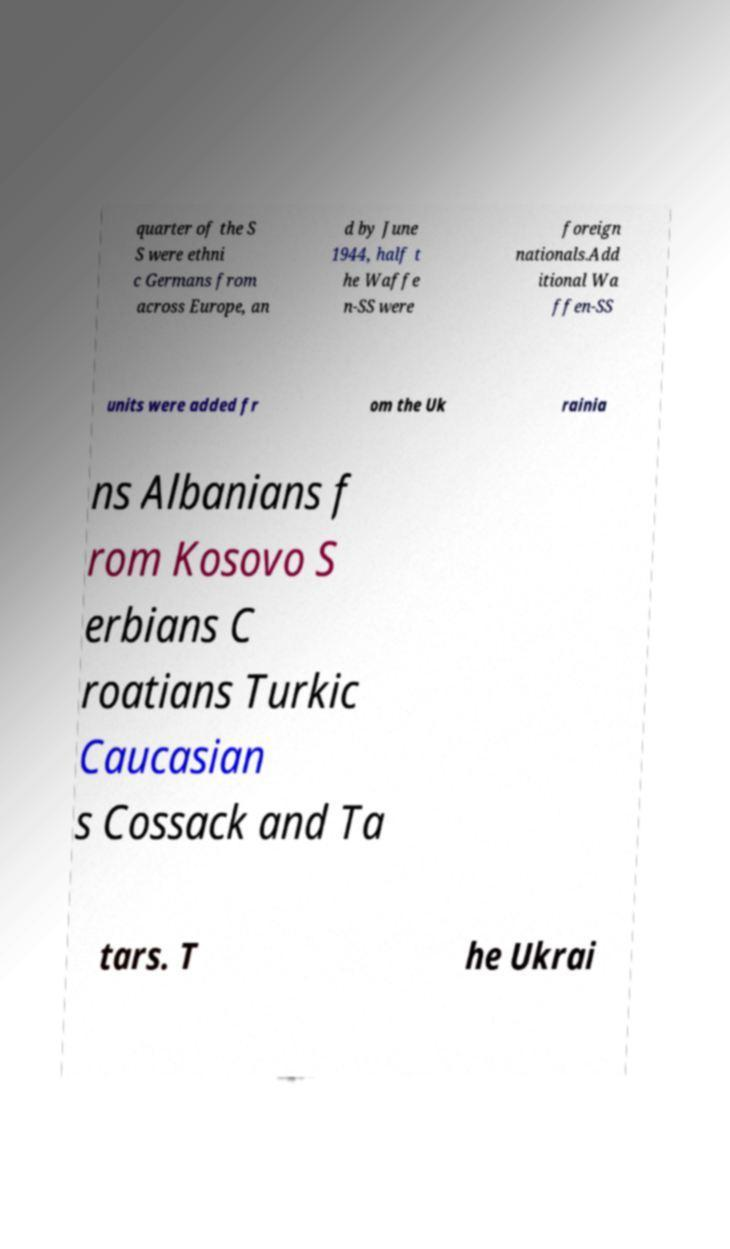Please identify and transcribe the text found in this image. quarter of the S S were ethni c Germans from across Europe, an d by June 1944, half t he Waffe n-SS were foreign nationals.Add itional Wa ffen-SS units were added fr om the Uk rainia ns Albanians f rom Kosovo S erbians C roatians Turkic Caucasian s Cossack and Ta tars. T he Ukrai 